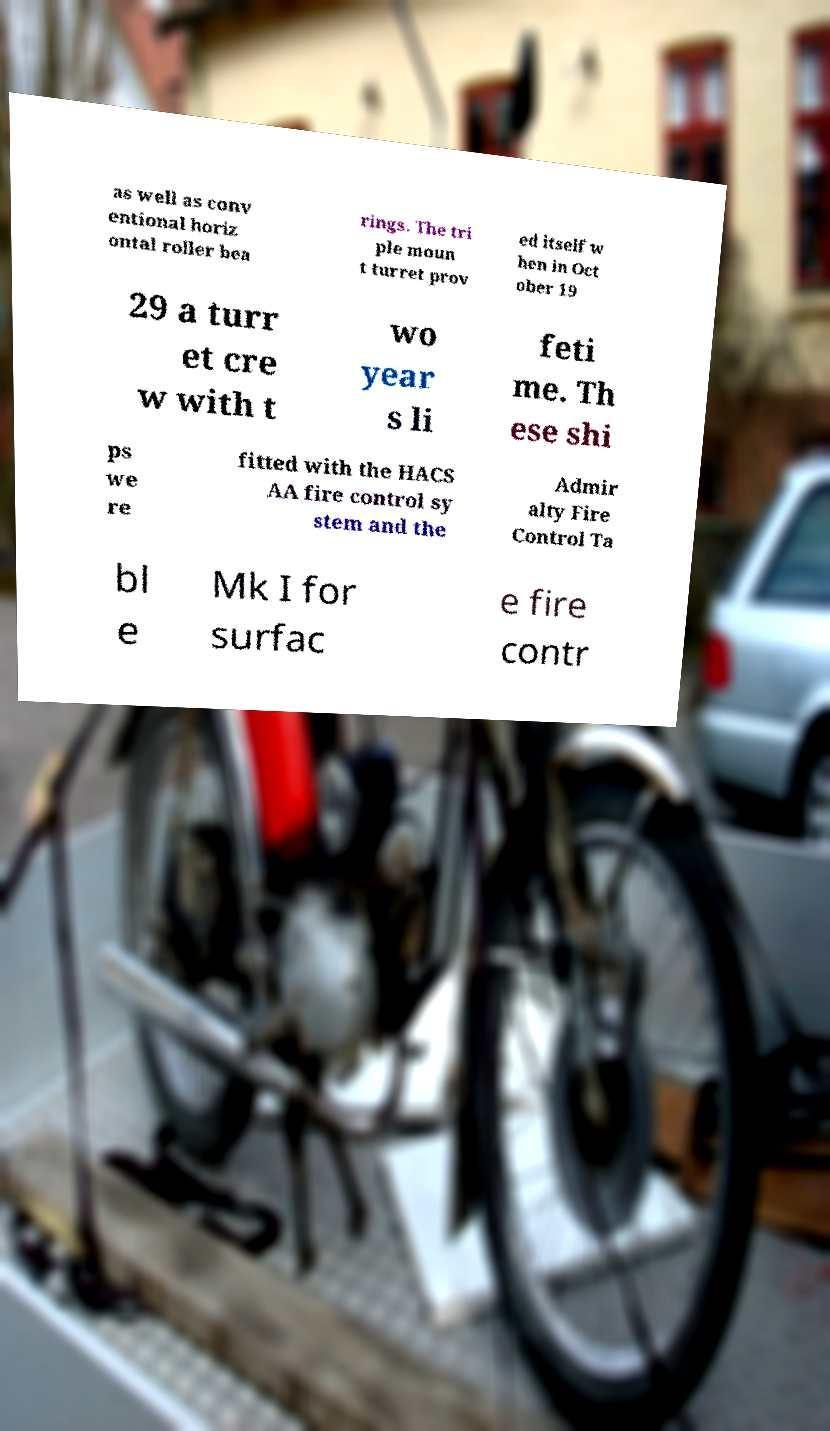Please identify and transcribe the text found in this image. as well as conv entional horiz ontal roller bea rings. The tri ple moun t turret prov ed itself w hen in Oct ober 19 29 a turr et cre w with t wo year s li feti me. Th ese shi ps we re fitted with the HACS AA fire control sy stem and the Admir alty Fire Control Ta bl e Mk I for surfac e fire contr 